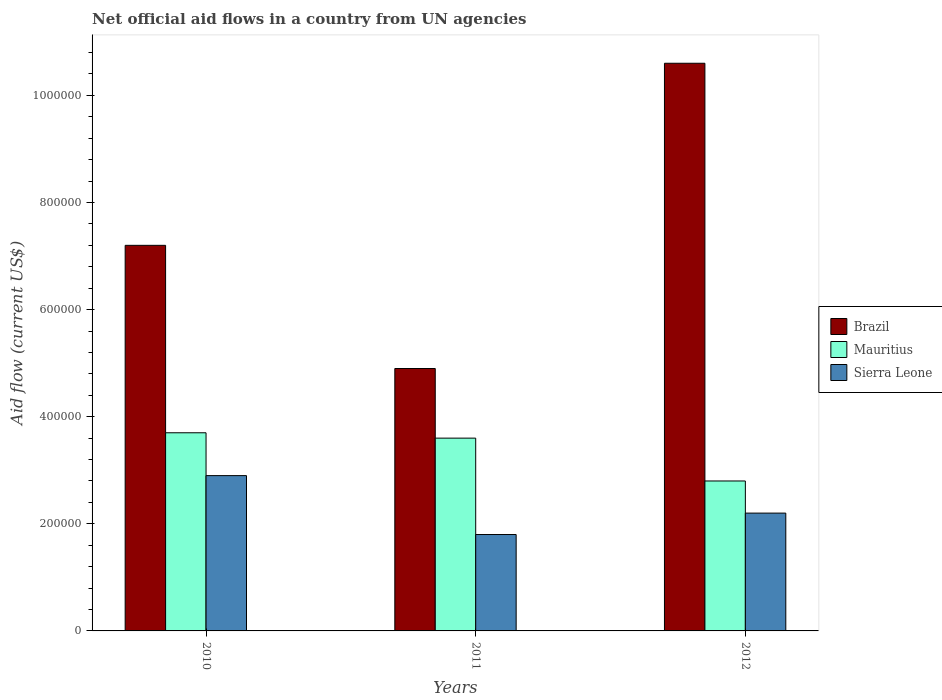How many different coloured bars are there?
Make the answer very short. 3. How many groups of bars are there?
Your response must be concise. 3. Are the number of bars per tick equal to the number of legend labels?
Make the answer very short. Yes. Are the number of bars on each tick of the X-axis equal?
Provide a succinct answer. Yes. How many bars are there on the 1st tick from the left?
Your answer should be compact. 3. How many bars are there on the 2nd tick from the right?
Provide a short and direct response. 3. What is the net official aid flow in Brazil in 2010?
Give a very brief answer. 7.20e+05. Across all years, what is the maximum net official aid flow in Brazil?
Provide a short and direct response. 1.06e+06. Across all years, what is the minimum net official aid flow in Sierra Leone?
Your response must be concise. 1.80e+05. What is the total net official aid flow in Mauritius in the graph?
Your response must be concise. 1.01e+06. What is the difference between the net official aid flow in Mauritius in 2010 and that in 2011?
Offer a very short reply. 10000. What is the difference between the net official aid flow in Brazil in 2011 and the net official aid flow in Sierra Leone in 2012?
Ensure brevity in your answer.  2.70e+05. What is the average net official aid flow in Brazil per year?
Keep it short and to the point. 7.57e+05. In the year 2010, what is the difference between the net official aid flow in Mauritius and net official aid flow in Sierra Leone?
Offer a terse response. 8.00e+04. What is the ratio of the net official aid flow in Brazil in 2011 to that in 2012?
Provide a short and direct response. 0.46. Is the net official aid flow in Brazil in 2011 less than that in 2012?
Make the answer very short. Yes. Is the difference between the net official aid flow in Mauritius in 2010 and 2011 greater than the difference between the net official aid flow in Sierra Leone in 2010 and 2011?
Your answer should be very brief. No. What is the difference between the highest and the lowest net official aid flow in Sierra Leone?
Ensure brevity in your answer.  1.10e+05. What does the 1st bar from the left in 2010 represents?
Your response must be concise. Brazil. What does the 2nd bar from the right in 2012 represents?
Provide a short and direct response. Mauritius. Are all the bars in the graph horizontal?
Make the answer very short. No. What is the difference between two consecutive major ticks on the Y-axis?
Keep it short and to the point. 2.00e+05. Are the values on the major ticks of Y-axis written in scientific E-notation?
Offer a terse response. No. Does the graph contain any zero values?
Keep it short and to the point. No. How are the legend labels stacked?
Offer a very short reply. Vertical. What is the title of the graph?
Keep it short and to the point. Net official aid flows in a country from UN agencies. What is the label or title of the Y-axis?
Offer a very short reply. Aid flow (current US$). What is the Aid flow (current US$) of Brazil in 2010?
Ensure brevity in your answer.  7.20e+05. What is the Aid flow (current US$) in Mauritius in 2010?
Provide a short and direct response. 3.70e+05. What is the Aid flow (current US$) in Sierra Leone in 2010?
Keep it short and to the point. 2.90e+05. What is the Aid flow (current US$) in Mauritius in 2011?
Make the answer very short. 3.60e+05. What is the Aid flow (current US$) in Sierra Leone in 2011?
Make the answer very short. 1.80e+05. What is the Aid flow (current US$) in Brazil in 2012?
Keep it short and to the point. 1.06e+06. What is the Aid flow (current US$) in Sierra Leone in 2012?
Provide a succinct answer. 2.20e+05. Across all years, what is the maximum Aid flow (current US$) in Brazil?
Your response must be concise. 1.06e+06. Across all years, what is the minimum Aid flow (current US$) in Brazil?
Your answer should be compact. 4.90e+05. Across all years, what is the minimum Aid flow (current US$) in Sierra Leone?
Your answer should be very brief. 1.80e+05. What is the total Aid flow (current US$) in Brazil in the graph?
Give a very brief answer. 2.27e+06. What is the total Aid flow (current US$) of Mauritius in the graph?
Provide a succinct answer. 1.01e+06. What is the total Aid flow (current US$) in Sierra Leone in the graph?
Keep it short and to the point. 6.90e+05. What is the difference between the Aid flow (current US$) in Sierra Leone in 2010 and that in 2011?
Offer a terse response. 1.10e+05. What is the difference between the Aid flow (current US$) of Brazil in 2010 and that in 2012?
Your response must be concise. -3.40e+05. What is the difference between the Aid flow (current US$) in Brazil in 2011 and that in 2012?
Give a very brief answer. -5.70e+05. What is the difference between the Aid flow (current US$) in Mauritius in 2011 and that in 2012?
Offer a terse response. 8.00e+04. What is the difference between the Aid flow (current US$) of Brazil in 2010 and the Aid flow (current US$) of Sierra Leone in 2011?
Make the answer very short. 5.40e+05. What is the difference between the Aid flow (current US$) in Brazil in 2010 and the Aid flow (current US$) in Mauritius in 2012?
Give a very brief answer. 4.40e+05. What is the difference between the Aid flow (current US$) in Mauritius in 2010 and the Aid flow (current US$) in Sierra Leone in 2012?
Give a very brief answer. 1.50e+05. What is the difference between the Aid flow (current US$) of Brazil in 2011 and the Aid flow (current US$) of Sierra Leone in 2012?
Your response must be concise. 2.70e+05. What is the difference between the Aid flow (current US$) in Mauritius in 2011 and the Aid flow (current US$) in Sierra Leone in 2012?
Give a very brief answer. 1.40e+05. What is the average Aid flow (current US$) in Brazil per year?
Provide a succinct answer. 7.57e+05. What is the average Aid flow (current US$) in Mauritius per year?
Your response must be concise. 3.37e+05. In the year 2010, what is the difference between the Aid flow (current US$) in Brazil and Aid flow (current US$) in Sierra Leone?
Your answer should be very brief. 4.30e+05. In the year 2011, what is the difference between the Aid flow (current US$) in Brazil and Aid flow (current US$) in Sierra Leone?
Provide a succinct answer. 3.10e+05. In the year 2012, what is the difference between the Aid flow (current US$) in Brazil and Aid flow (current US$) in Mauritius?
Give a very brief answer. 7.80e+05. In the year 2012, what is the difference between the Aid flow (current US$) of Brazil and Aid flow (current US$) of Sierra Leone?
Ensure brevity in your answer.  8.40e+05. In the year 2012, what is the difference between the Aid flow (current US$) of Mauritius and Aid flow (current US$) of Sierra Leone?
Your response must be concise. 6.00e+04. What is the ratio of the Aid flow (current US$) of Brazil in 2010 to that in 2011?
Your answer should be very brief. 1.47. What is the ratio of the Aid flow (current US$) of Mauritius in 2010 to that in 2011?
Your response must be concise. 1.03. What is the ratio of the Aid flow (current US$) in Sierra Leone in 2010 to that in 2011?
Provide a succinct answer. 1.61. What is the ratio of the Aid flow (current US$) of Brazil in 2010 to that in 2012?
Give a very brief answer. 0.68. What is the ratio of the Aid flow (current US$) of Mauritius in 2010 to that in 2012?
Offer a terse response. 1.32. What is the ratio of the Aid flow (current US$) of Sierra Leone in 2010 to that in 2012?
Give a very brief answer. 1.32. What is the ratio of the Aid flow (current US$) in Brazil in 2011 to that in 2012?
Make the answer very short. 0.46. What is the ratio of the Aid flow (current US$) in Mauritius in 2011 to that in 2012?
Your answer should be compact. 1.29. What is the ratio of the Aid flow (current US$) in Sierra Leone in 2011 to that in 2012?
Your response must be concise. 0.82. What is the difference between the highest and the second highest Aid flow (current US$) in Mauritius?
Your response must be concise. 10000. What is the difference between the highest and the second highest Aid flow (current US$) in Sierra Leone?
Offer a terse response. 7.00e+04. What is the difference between the highest and the lowest Aid flow (current US$) of Brazil?
Your response must be concise. 5.70e+05. What is the difference between the highest and the lowest Aid flow (current US$) of Mauritius?
Keep it short and to the point. 9.00e+04. 